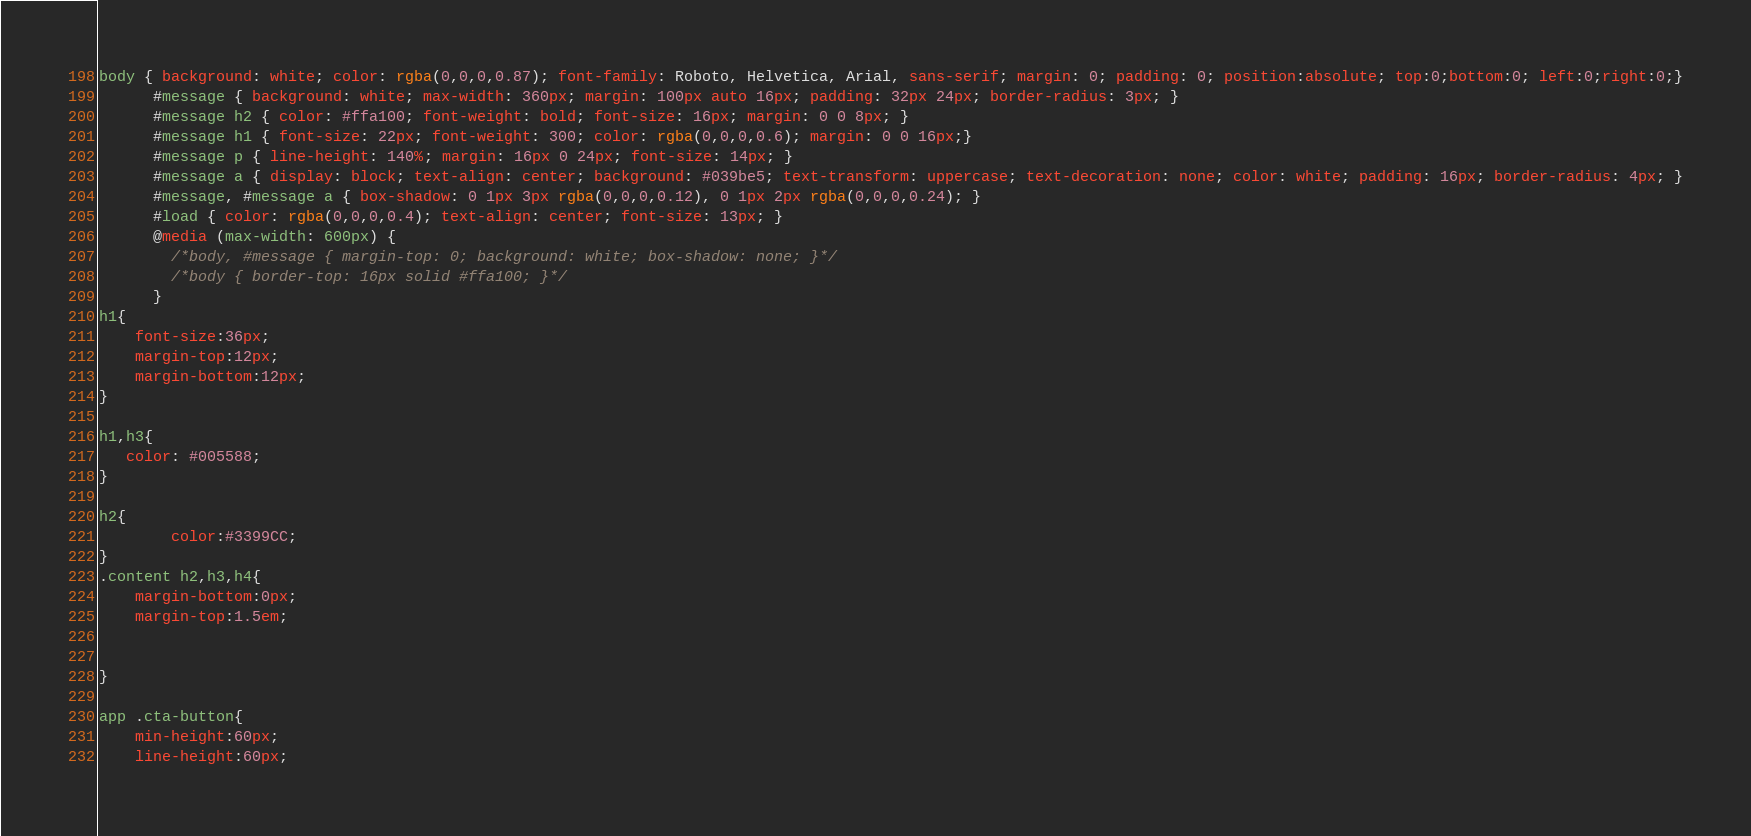<code> <loc_0><loc_0><loc_500><loc_500><_CSS_>body { background: white; color: rgba(0,0,0,0.87); font-family: Roboto, Helvetica, Arial, sans-serif; margin: 0; padding: 0; position:absolute; top:0;bottom:0; left:0;right:0;}
      #message { background: white; max-width: 360px; margin: 100px auto 16px; padding: 32px 24px; border-radius: 3px; }
      #message h2 { color: #ffa100; font-weight: bold; font-size: 16px; margin: 0 0 8px; }
      #message h1 { font-size: 22px; font-weight: 300; color: rgba(0,0,0,0.6); margin: 0 0 16px;}
      #message p { line-height: 140%; margin: 16px 0 24px; font-size: 14px; }
      #message a { display: block; text-align: center; background: #039be5; text-transform: uppercase; text-decoration: none; color: white; padding: 16px; border-radius: 4px; }
      #message, #message a { box-shadow: 0 1px 3px rgba(0,0,0,0.12), 0 1px 2px rgba(0,0,0,0.24); }
      #load { color: rgba(0,0,0,0.4); text-align: center; font-size: 13px; }
      @media (max-width: 600px) {
        /*body, #message { margin-top: 0; background: white; box-shadow: none; }*/
        /*body { border-top: 16px solid #ffa100; }*/
      }
h1{
    font-size:36px;
    margin-top:12px;
    margin-bottom:12px;
}

h1,h3{
   color: #005588;
}

h2{
        color:#3399CC;
}
.content h2,h3,h4{
    margin-bottom:0px;
    margin-top:1.5em;
    

}

app .cta-button{
    min-height:60px;
    line-height:60px;</code> 